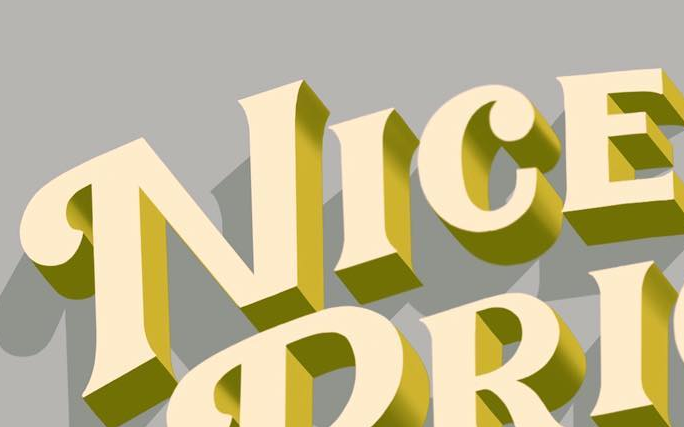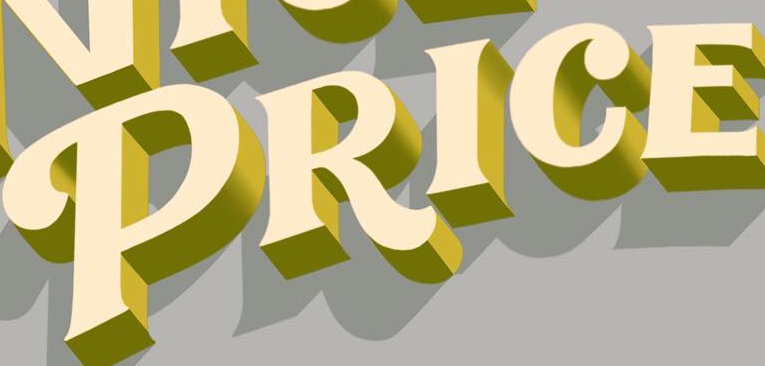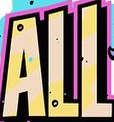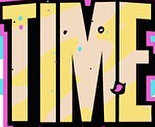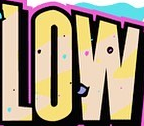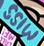What text appears in these images from left to right, separated by a semicolon? NICE; PRICE; ALL; TIME; LOW; MISS 